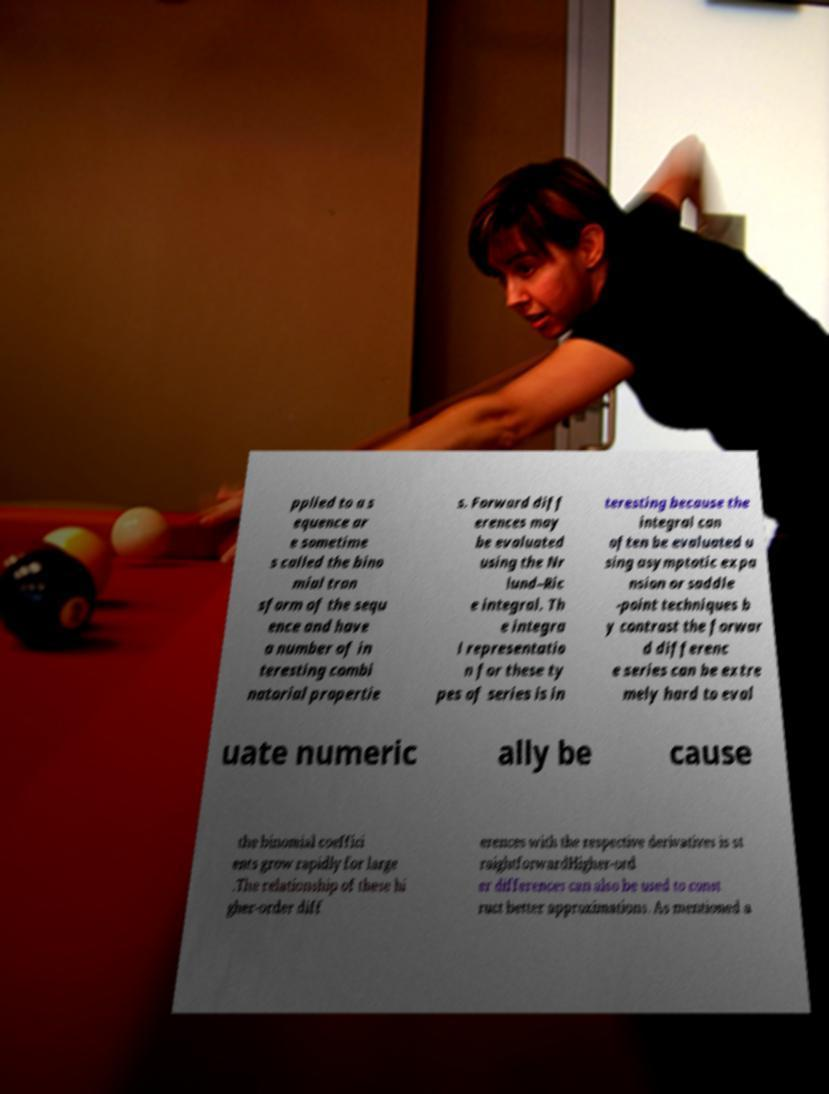What messages or text are displayed in this image? I need them in a readable, typed format. pplied to a s equence ar e sometime s called the bino mial tran sform of the sequ ence and have a number of in teresting combi natorial propertie s. Forward diff erences may be evaluated using the Nr lund–Ric e integral. Th e integra l representatio n for these ty pes of series is in teresting because the integral can often be evaluated u sing asymptotic expa nsion or saddle -point techniques b y contrast the forwar d differenc e series can be extre mely hard to eval uate numeric ally be cause the binomial coeffici ents grow rapidly for large .The relationship of these hi gher-order diff erences with the respective derivatives is st raightforwardHigher-ord er differences can also be used to const ruct better approximations. As mentioned a 